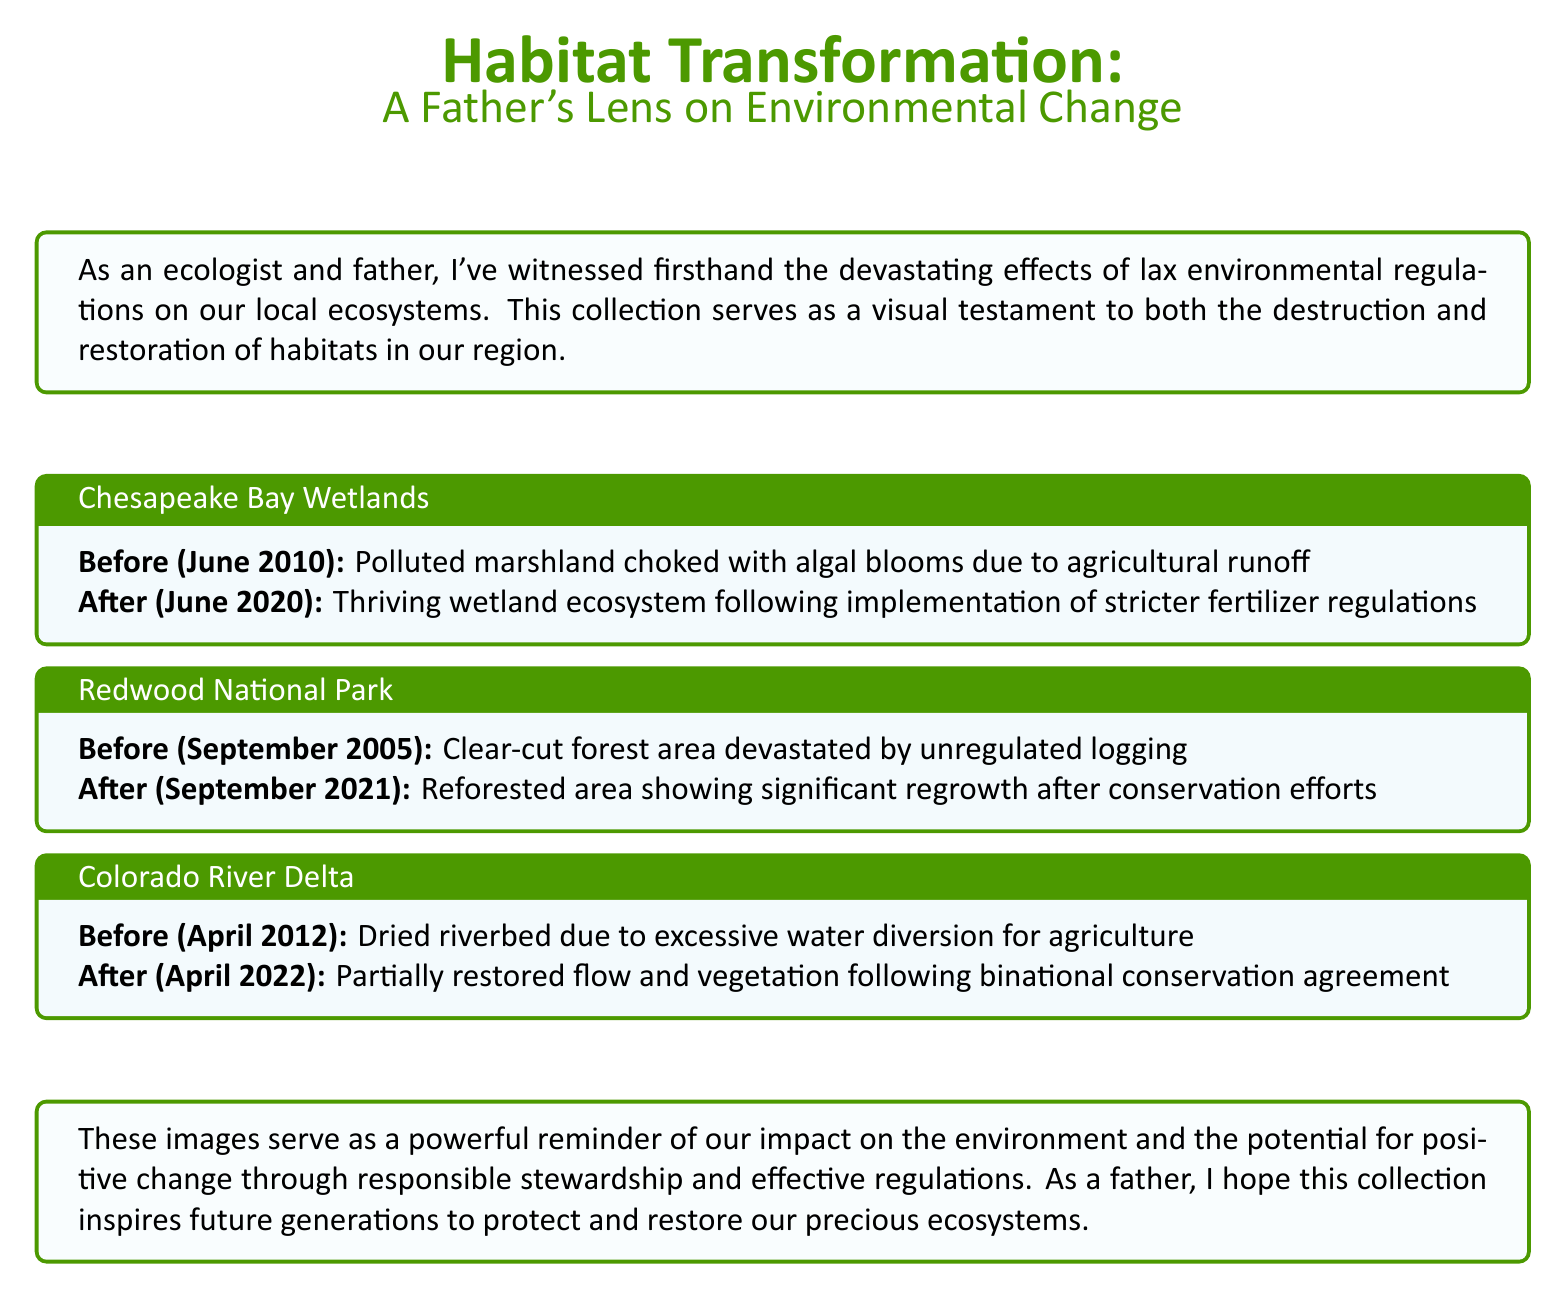What is the title of the collection? The title is stated at the beginning of the document and reflects the themes of habitat transformation and personal experience.
Answer: Habitat Transformation: A Father's Lens on Environmental Change What is the date of the Chesapeake Bay Wetlands photograph? The document states the date for the before and after images of Chesapeake Bay Wetlands.
Answer: June 2010 What significant environmental issue does the Chesapeake Bay Wetlands image highlight? The description emphasizes the pollution caused by agricultural runoff and its effects on the marshland.
Answer: Algal blooms What type of restoration occurred in Redwood National Park? The document describes the outcome of conservation efforts that led to a recovery in the area previously affected by logging.
Answer: Reforested area What agreement helped restore the Colorado River Delta? The document notes a specific type of agreement that facilitated restoration and flow improvement in the region.
Answer: Binational conservation agreement What year did the Redwoods National Park restoration start? The restoration display for Redwood National Park shows the year when the area was last clear-cut before the restoration efforts.
Answer: 2005 What color is used for the section titles in the document? The document describes the color utilized for section titles, which enhances the visual appeal and thematic relevance.
Answer: Earthgreen How many years passed between the before and after images of the Colorado River Delta? The document requires calculating the time difference between the two dates mentioned for the Colorado River Delta images.
Answer: 10 years What is the main theme of the collection according to the introduction? The introduction summarizes the overall message regarding ecological changes due to human actions and the potential for positive outcomes.
Answer: Environmental change 